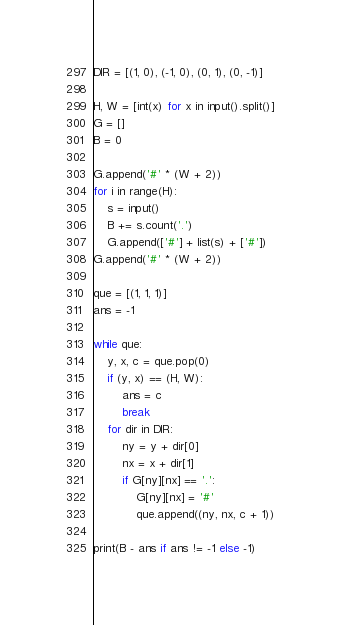<code> <loc_0><loc_0><loc_500><loc_500><_Python_>DIR = [(1, 0), (-1, 0), (0, 1), (0, -1)]

H, W = [int(x) for x in input().split()]
G = []
B = 0

G.append('#' * (W + 2))
for i in range(H):
    s = input()
    B += s.count('.')
    G.append(['#'] + list(s) + ['#'])
G.append('#' * (W + 2))

que = [(1, 1, 1)]
ans = -1

while que:
    y, x, c = que.pop(0)
    if (y, x) == (H, W):
        ans = c
        break
    for dir in DIR:
        ny = y + dir[0]
        nx = x + dir[1]
        if G[ny][nx] == '.':
            G[ny][nx] = '#'
            que.append((ny, nx, c + 1))

print(B - ans if ans != -1 else -1)</code> 